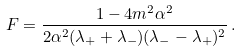Convert formula to latex. <formula><loc_0><loc_0><loc_500><loc_500>F = \frac { 1 - 4 m ^ { 2 } \alpha ^ { 2 } } { 2 \alpha ^ { 2 } ( \lambda _ { + } + \lambda _ { - } ) ( \lambda _ { - } - \lambda _ { + } ) ^ { 2 } } \, .</formula> 